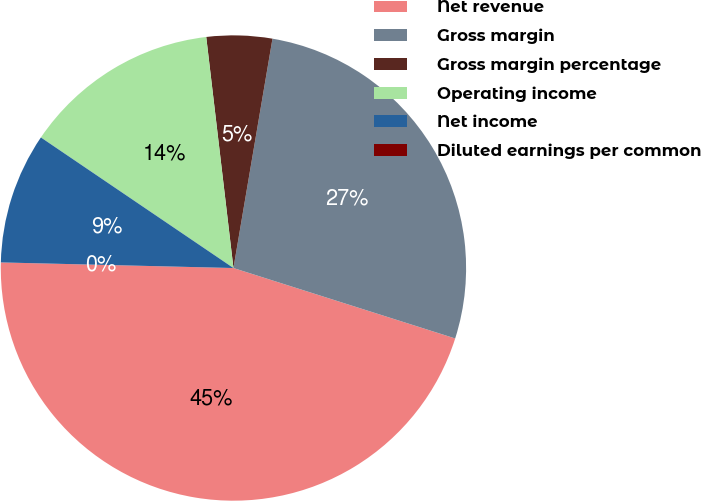Convert chart. <chart><loc_0><loc_0><loc_500><loc_500><pie_chart><fcel>Net revenue<fcel>Gross margin<fcel>Gross margin percentage<fcel>Operating income<fcel>Net income<fcel>Diluted earnings per common<nl><fcel>45.49%<fcel>27.21%<fcel>4.55%<fcel>13.65%<fcel>9.1%<fcel>0.0%<nl></chart> 